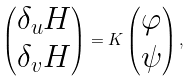Convert formula to latex. <formula><loc_0><loc_0><loc_500><loc_500>\left ( \begin{matrix} \delta _ { u } H \\ \delta _ { v } H \end{matrix} \right ) = K \left ( \begin{matrix} \varphi \\ \psi \end{matrix} \right ) ,</formula> 